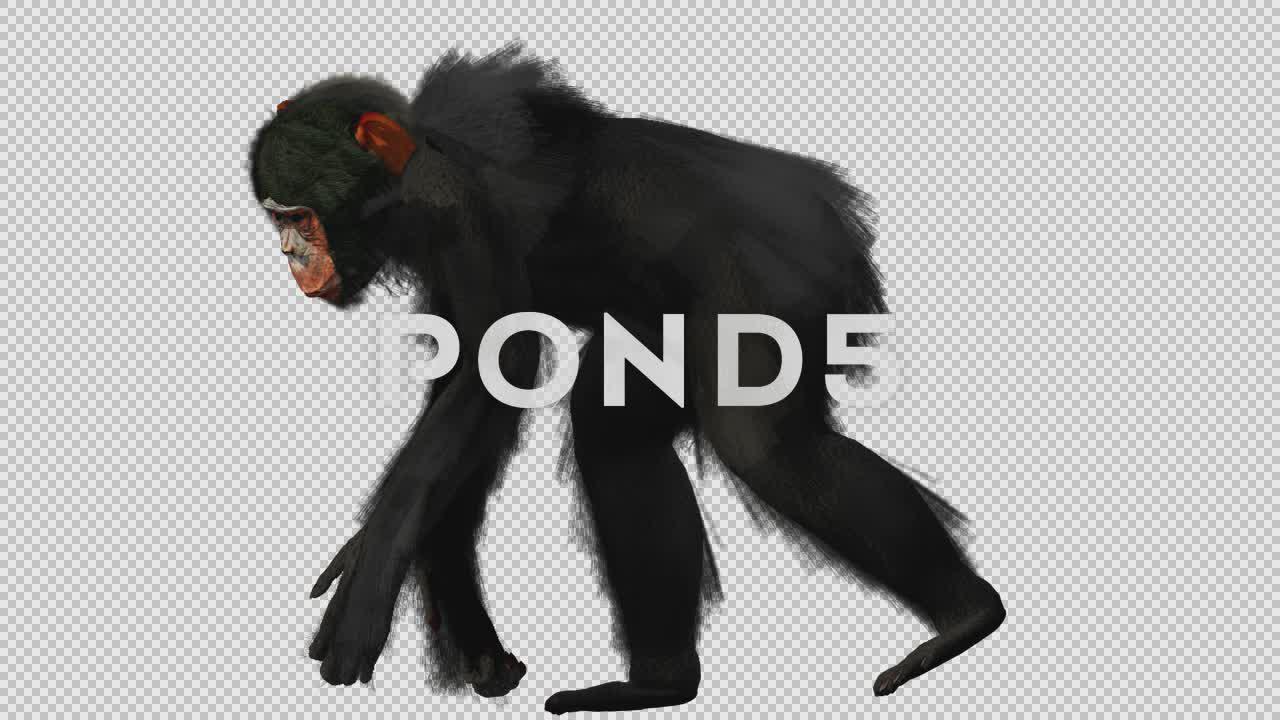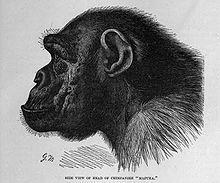The first image is the image on the left, the second image is the image on the right. Given the left and right images, does the statement "One chimp is standing on four feet." hold true? Answer yes or no. Yes. The first image is the image on the left, the second image is the image on the right. For the images shown, is this caption "In one of the images a monkey is on all four legs." true? Answer yes or no. Yes. 